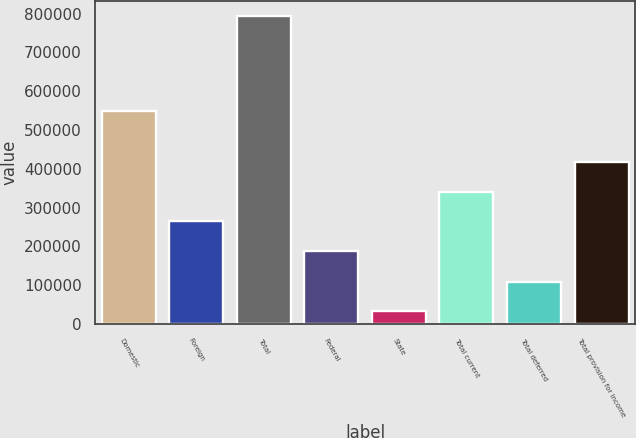Convert chart to OTSL. <chart><loc_0><loc_0><loc_500><loc_500><bar_chart><fcel>Domestic<fcel>Foreign<fcel>Total<fcel>Federal<fcel>State<fcel>Total current<fcel>Total deferred<fcel>Total provision for income<nl><fcel>547757<fcel>264582<fcel>793412<fcel>188600<fcel>33595<fcel>340563<fcel>109577<fcel>416545<nl></chart> 